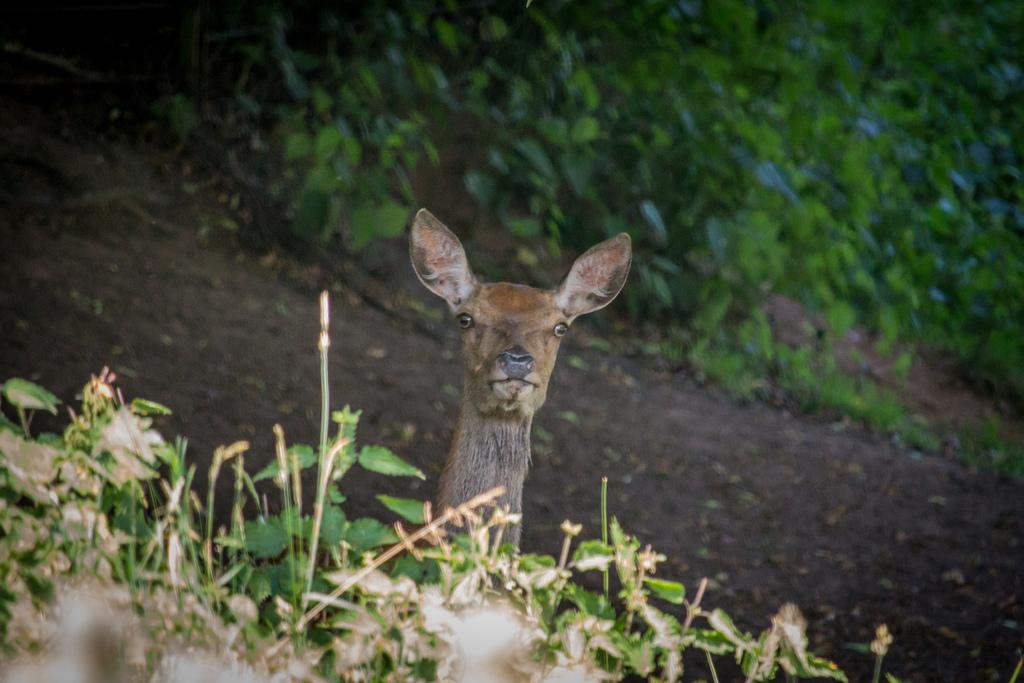What type of animal is present in the image? There is a deer in the image. What other elements can be seen in the image besides the deer? There are plants visible in the image. How would you describe the background of the image? The background of the image is blurred. What type of ring is the deer wearing on its leg in the image? There is no ring or any indication of a ring on the deer's leg in the image. 